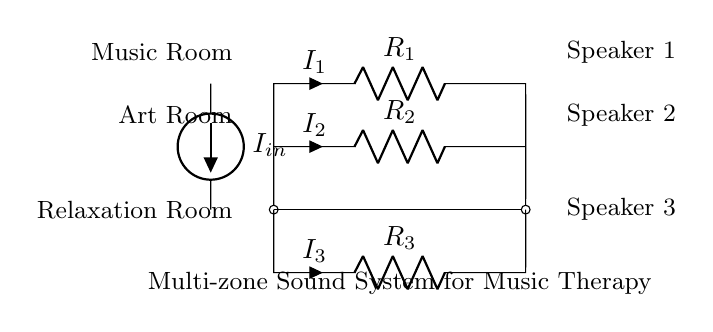What is the total current entering the circuit? The total current entering the circuit is represented as I in the diagram, labeled as I in the current source.
Answer: I in What are the values of the resistors in the circuit? The resistors are labeled as R1, R2, and R3, but their numeric values are not specified in the diagram. They represent different resistance values for the current divider.
Answer: R1, R2, R3 How many output paths does the circuit have? The circuit has three output paths, corresponding to the three resistors (R1, R2, R3) which distribute the current to the speakers.
Answer: Three Which room corresponds to R3 in the circuit? R3 is connected to the Relaxation Room, which is indicated in the diagram near the bottom where R3 is labeled.
Answer: Relaxation Room What happens to the total current as it passes through the resistors? As the total current passes through the resistors, it splits into smaller currents (I1, I2, I3), based on the resistance values, following the principle of a current divider.
Answer: Splits into smaller currents Which speaker is connected to R2? Speaker 2 is connected to R2, as indicated by the label next to the resistor in the diagram at the corresponding position for the Art Room.
Answer: Speaker 2 